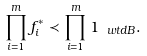Convert formula to latex. <formula><loc_0><loc_0><loc_500><loc_500>\prod _ { i = 1 } ^ { m } f _ { i } ^ { \ast } \prec \prod _ { i = 1 } ^ { m } { 1 } _ { \ w t d { B } } .</formula> 